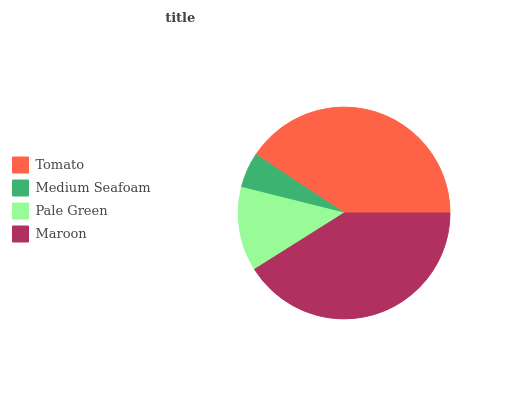Is Medium Seafoam the minimum?
Answer yes or no. Yes. Is Maroon the maximum?
Answer yes or no. Yes. Is Pale Green the minimum?
Answer yes or no. No. Is Pale Green the maximum?
Answer yes or no. No. Is Pale Green greater than Medium Seafoam?
Answer yes or no. Yes. Is Medium Seafoam less than Pale Green?
Answer yes or no. Yes. Is Medium Seafoam greater than Pale Green?
Answer yes or no. No. Is Pale Green less than Medium Seafoam?
Answer yes or no. No. Is Tomato the high median?
Answer yes or no. Yes. Is Pale Green the low median?
Answer yes or no. Yes. Is Pale Green the high median?
Answer yes or no. No. Is Maroon the low median?
Answer yes or no. No. 